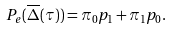Convert formula to latex. <formula><loc_0><loc_0><loc_500><loc_500>P _ { e } ( \overline { \Delta } ( \tau ) ) = \pi _ { 0 } p _ { 1 } + \pi _ { 1 } p _ { 0 } .</formula> 